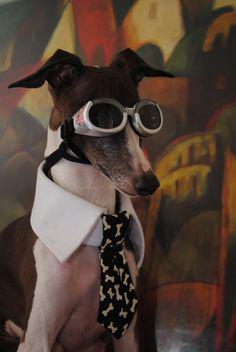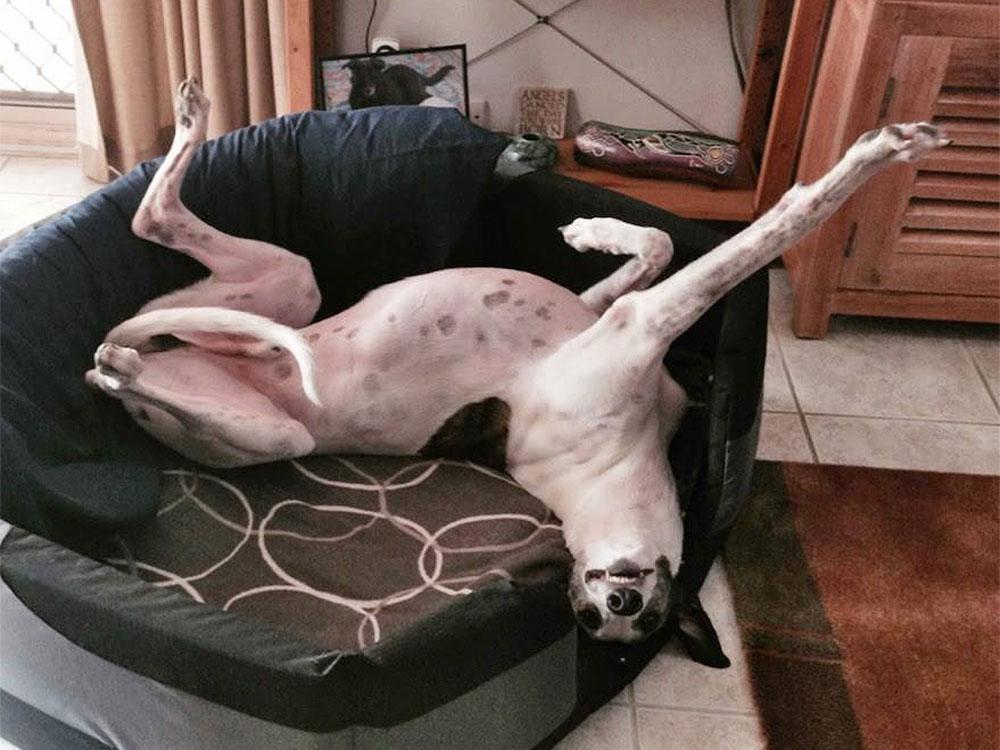The first image is the image on the left, the second image is the image on the right. For the images displayed, is the sentence "One image features a hound wearing a hat, and no image shows more than one hound figure." factually correct? Answer yes or no. No. The first image is the image on the left, the second image is the image on the right. For the images shown, is this caption "At least one of the dogs has a hat on its head." true? Answer yes or no. No. 